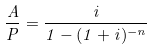<formula> <loc_0><loc_0><loc_500><loc_500>\frac { A } { P } = \frac { i } { 1 - ( 1 + i ) ^ { - n } }</formula> 